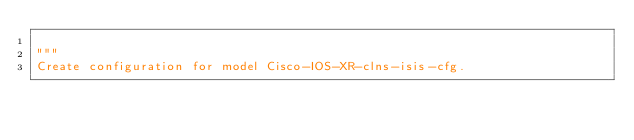Convert code to text. <code><loc_0><loc_0><loc_500><loc_500><_Python_>
"""
Create configuration for model Cisco-IOS-XR-clns-isis-cfg.
</code> 